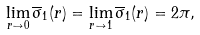<formula> <loc_0><loc_0><loc_500><loc_500>\lim _ { r \to 0 } \overline { \sigma } _ { 1 } ( r ) = \lim _ { r \to 1 } \overline { \sigma } _ { 1 } ( r ) = 2 \pi ,</formula> 